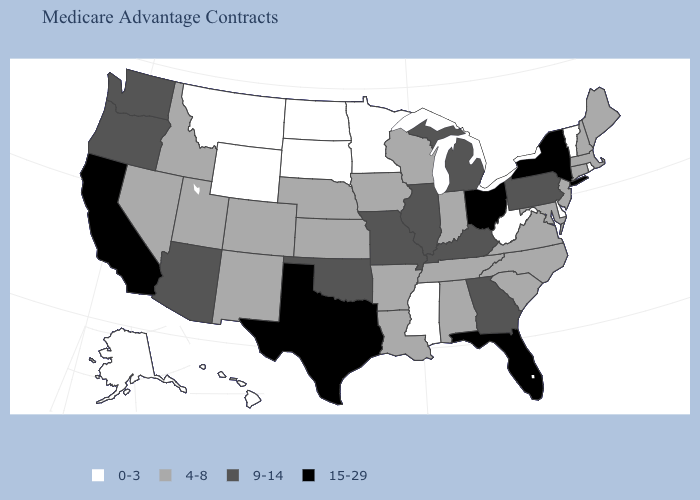Name the states that have a value in the range 0-3?
Write a very short answer. Alaska, Delaware, Hawaii, Minnesota, Mississippi, Montana, North Dakota, Rhode Island, South Dakota, Vermont, West Virginia, Wyoming. What is the highest value in the Northeast ?
Short answer required. 15-29. Among the states that border Rhode Island , which have the lowest value?
Quick response, please. Connecticut, Massachusetts. What is the highest value in the USA?
Be succinct. 15-29. Name the states that have a value in the range 4-8?
Concise answer only. Alabama, Arkansas, Colorado, Connecticut, Iowa, Idaho, Indiana, Kansas, Louisiana, Massachusetts, Maryland, Maine, North Carolina, Nebraska, New Hampshire, New Jersey, New Mexico, Nevada, South Carolina, Tennessee, Utah, Virginia, Wisconsin. What is the lowest value in the USA?
Be succinct. 0-3. Does California have the same value as Texas?
Give a very brief answer. Yes. Does Maine have a lower value than Oregon?
Give a very brief answer. Yes. Name the states that have a value in the range 15-29?
Be succinct. California, Florida, New York, Ohio, Texas. Does Ohio have the same value as California?
Concise answer only. Yes. What is the value of West Virginia?
Short answer required. 0-3. What is the highest value in states that border Missouri?
Be succinct. 9-14. Name the states that have a value in the range 4-8?
Give a very brief answer. Alabama, Arkansas, Colorado, Connecticut, Iowa, Idaho, Indiana, Kansas, Louisiana, Massachusetts, Maryland, Maine, North Carolina, Nebraska, New Hampshire, New Jersey, New Mexico, Nevada, South Carolina, Tennessee, Utah, Virginia, Wisconsin. Name the states that have a value in the range 4-8?
Answer briefly. Alabama, Arkansas, Colorado, Connecticut, Iowa, Idaho, Indiana, Kansas, Louisiana, Massachusetts, Maryland, Maine, North Carolina, Nebraska, New Hampshire, New Jersey, New Mexico, Nevada, South Carolina, Tennessee, Utah, Virginia, Wisconsin. Does the first symbol in the legend represent the smallest category?
Write a very short answer. Yes. 